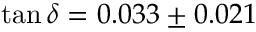<formula> <loc_0><loc_0><loc_500><loc_500>\tan { \delta } = 0 . 0 3 3 \pm 0 . 0 2 1</formula> 